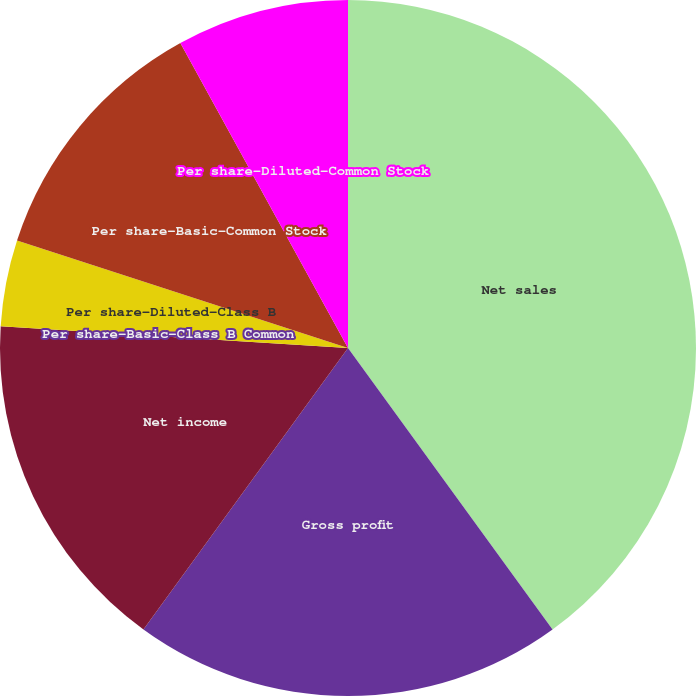Convert chart to OTSL. <chart><loc_0><loc_0><loc_500><loc_500><pie_chart><fcel>Net sales<fcel>Gross profit<fcel>Net income<fcel>Per share-Basic-Class B Common<fcel>Per share-Diluted-Class B<fcel>Per share-Basic-Common Stock<fcel>Per share-Diluted-Common Stock<nl><fcel>40.0%<fcel>20.0%<fcel>16.0%<fcel>0.0%<fcel>4.0%<fcel>12.0%<fcel>8.0%<nl></chart> 